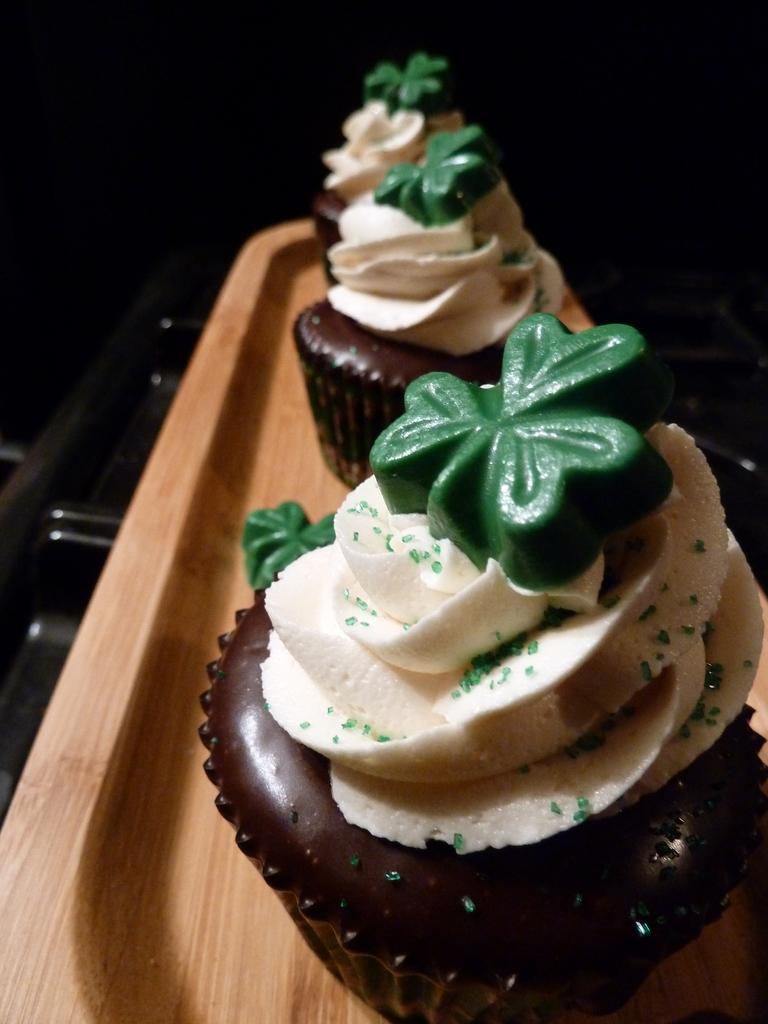How would you summarize this image in a sentence or two? In this picture I can observe cupcakes which are in brown and white colors. These cupcakes are placed in the wooden tray. The background is dark. 